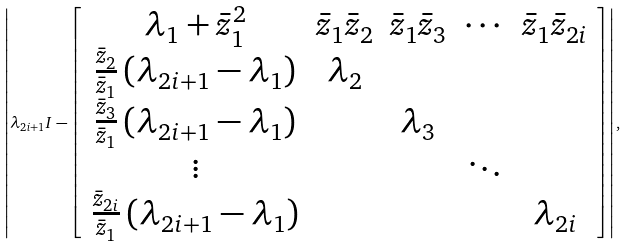<formula> <loc_0><loc_0><loc_500><loc_500>\left | \lambda _ { 2 i + 1 } I - \left [ \begin{array} { c c c c c } \lambda _ { 1 } + \bar { z } _ { 1 } ^ { 2 } & \bar { z } _ { 1 } \bar { z } _ { 2 } & \bar { z } _ { 1 } \bar { z } _ { 3 } & \cdots & \bar { z } _ { 1 } \bar { z } _ { 2 i } \\ \frac { \bar { z } _ { 2 } } { \bar { z } _ { 1 } } \left ( \lambda _ { 2 i + 1 } - \lambda _ { 1 } \right ) & \lambda _ { 2 } & & & \\ \frac { \bar { z } _ { 3 } } { \bar { z } _ { 1 } } \left ( \lambda _ { 2 i + 1 } - \lambda _ { 1 } \right ) & & \lambda _ { 3 } & & \\ \vdots & & & \ddots & \\ \frac { \bar { z } _ { 2 i } } { \bar { z } _ { 1 } } \left ( \lambda _ { 2 i + 1 } - \lambda _ { 1 } \right ) & & & & \lambda _ { 2 i } \end{array} \right ] \right | ,</formula> 